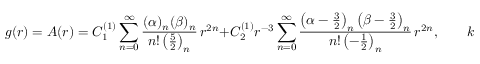<formula> <loc_0><loc_0><loc_500><loc_500>g ( r ) = A ( r ) = C _ { 1 } ^ { ( 1 ) } \sum _ { n = 0 } ^ { \infty } \frac { ( \alpha ) _ { n } ( \beta ) _ { n } } { n ! \left ( \frac { 5 } { 2 } \right ) _ { n } } \, r ^ { 2 n } + C _ { 2 } ^ { ( 1 ) } r ^ { - 3 } \sum _ { n = 0 } ^ { \infty } \frac { \left ( \alpha - \frac { 3 } { 2 } \right ) _ { n } \left ( \beta - \frac { 3 } { 2 } \right ) _ { n } } { n ! \left ( - \frac { 1 } { 2 } \right ) _ { n } } \, r ^ { 2 n } , \quad k = + 1 .</formula> 